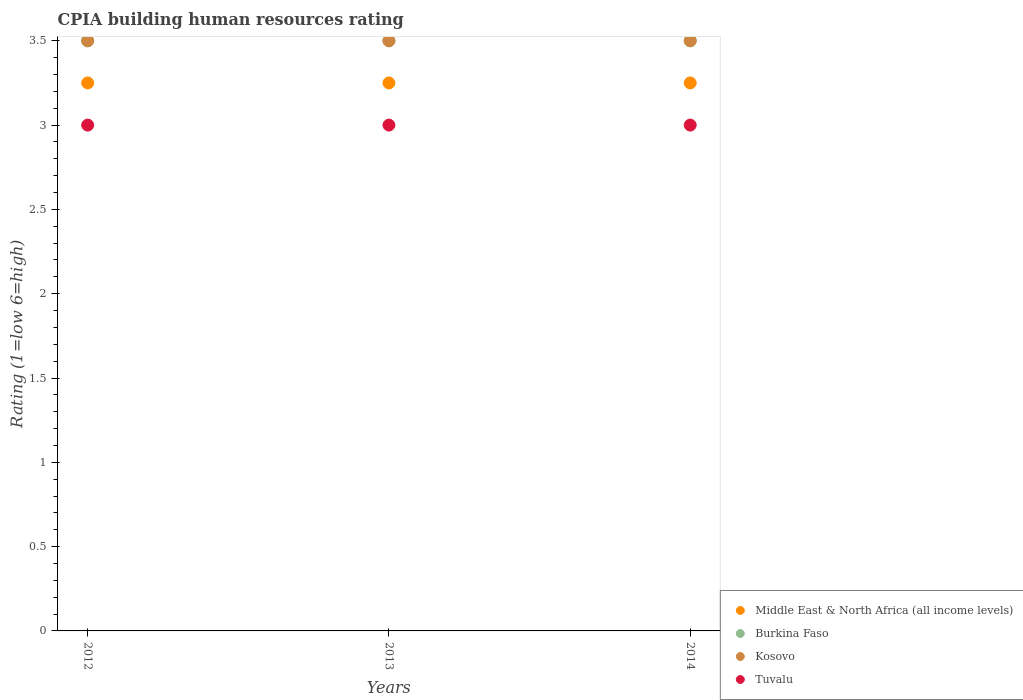What is the CPIA rating in Middle East & North Africa (all income levels) in 2014?
Give a very brief answer. 3.25. Across all years, what is the maximum CPIA rating in Burkina Faso?
Ensure brevity in your answer.  3.5. In which year was the CPIA rating in Tuvalu maximum?
Your response must be concise. 2012. In which year was the CPIA rating in Tuvalu minimum?
Your response must be concise. 2012. What is the total CPIA rating in Middle East & North Africa (all income levels) in the graph?
Provide a short and direct response. 9.75. What is the difference between the CPIA rating in Tuvalu in 2012 and that in 2014?
Your response must be concise. 0. In the year 2013, what is the difference between the CPIA rating in Kosovo and CPIA rating in Middle East & North Africa (all income levels)?
Ensure brevity in your answer.  0.25. In how many years, is the CPIA rating in Middle East & North Africa (all income levels) greater than 1.8?
Keep it short and to the point. 3. What is the ratio of the CPIA rating in Middle East & North Africa (all income levels) in 2012 to that in 2013?
Make the answer very short. 1. Is the difference between the CPIA rating in Kosovo in 2013 and 2014 greater than the difference between the CPIA rating in Middle East & North Africa (all income levels) in 2013 and 2014?
Your answer should be compact. No. What is the difference between the highest and the second highest CPIA rating in Middle East & North Africa (all income levels)?
Ensure brevity in your answer.  0. In how many years, is the CPIA rating in Middle East & North Africa (all income levels) greater than the average CPIA rating in Middle East & North Africa (all income levels) taken over all years?
Offer a terse response. 0. Is the sum of the CPIA rating in Burkina Faso in 2013 and 2014 greater than the maximum CPIA rating in Kosovo across all years?
Provide a succinct answer. Yes. Is it the case that in every year, the sum of the CPIA rating in Tuvalu and CPIA rating in Kosovo  is greater than the sum of CPIA rating in Middle East & North Africa (all income levels) and CPIA rating in Burkina Faso?
Your response must be concise. No. Are the values on the major ticks of Y-axis written in scientific E-notation?
Keep it short and to the point. No. How are the legend labels stacked?
Offer a terse response. Vertical. What is the title of the graph?
Provide a succinct answer. CPIA building human resources rating. What is the label or title of the Y-axis?
Offer a terse response. Rating (1=low 6=high). What is the Rating (1=low 6=high) of Burkina Faso in 2012?
Make the answer very short. 3.5. What is the Rating (1=low 6=high) in Kosovo in 2012?
Make the answer very short. 3.5. What is the Rating (1=low 6=high) in Tuvalu in 2012?
Your answer should be compact. 3. What is the Rating (1=low 6=high) in Middle East & North Africa (all income levels) in 2013?
Provide a succinct answer. 3.25. What is the Rating (1=low 6=high) in Burkina Faso in 2013?
Provide a succinct answer. 3.5. What is the Rating (1=low 6=high) of Kosovo in 2013?
Make the answer very short. 3.5. What is the Rating (1=low 6=high) in Tuvalu in 2013?
Provide a succinct answer. 3. What is the Rating (1=low 6=high) in Middle East & North Africa (all income levels) in 2014?
Your answer should be very brief. 3.25. What is the Rating (1=low 6=high) of Kosovo in 2014?
Offer a very short reply. 3.5. Across all years, what is the maximum Rating (1=low 6=high) of Middle East & North Africa (all income levels)?
Keep it short and to the point. 3.25. Across all years, what is the minimum Rating (1=low 6=high) in Burkina Faso?
Your answer should be very brief. 3.5. Across all years, what is the minimum Rating (1=low 6=high) in Kosovo?
Your answer should be very brief. 3.5. Across all years, what is the minimum Rating (1=low 6=high) in Tuvalu?
Make the answer very short. 3. What is the total Rating (1=low 6=high) of Middle East & North Africa (all income levels) in the graph?
Ensure brevity in your answer.  9.75. What is the total Rating (1=low 6=high) of Kosovo in the graph?
Your response must be concise. 10.5. What is the difference between the Rating (1=low 6=high) in Middle East & North Africa (all income levels) in 2012 and that in 2013?
Keep it short and to the point. 0. What is the difference between the Rating (1=low 6=high) of Kosovo in 2012 and that in 2013?
Your answer should be very brief. 0. What is the difference between the Rating (1=low 6=high) in Tuvalu in 2012 and that in 2013?
Your response must be concise. 0. What is the difference between the Rating (1=low 6=high) in Middle East & North Africa (all income levels) in 2012 and that in 2014?
Provide a short and direct response. 0. What is the difference between the Rating (1=low 6=high) of Tuvalu in 2012 and that in 2014?
Keep it short and to the point. 0. What is the difference between the Rating (1=low 6=high) of Kosovo in 2013 and that in 2014?
Your answer should be compact. 0. What is the difference between the Rating (1=low 6=high) in Middle East & North Africa (all income levels) in 2012 and the Rating (1=low 6=high) in Burkina Faso in 2013?
Keep it short and to the point. -0.25. What is the difference between the Rating (1=low 6=high) of Burkina Faso in 2012 and the Rating (1=low 6=high) of Tuvalu in 2013?
Offer a very short reply. 0.5. What is the difference between the Rating (1=low 6=high) in Middle East & North Africa (all income levels) in 2012 and the Rating (1=low 6=high) in Kosovo in 2014?
Offer a very short reply. -0.25. What is the difference between the Rating (1=low 6=high) of Middle East & North Africa (all income levels) in 2013 and the Rating (1=low 6=high) of Burkina Faso in 2014?
Offer a very short reply. -0.25. What is the difference between the Rating (1=low 6=high) of Burkina Faso in 2013 and the Rating (1=low 6=high) of Kosovo in 2014?
Offer a terse response. 0. What is the difference between the Rating (1=low 6=high) in Kosovo in 2013 and the Rating (1=low 6=high) in Tuvalu in 2014?
Your response must be concise. 0.5. What is the average Rating (1=low 6=high) in Burkina Faso per year?
Keep it short and to the point. 3.5. What is the average Rating (1=low 6=high) in Tuvalu per year?
Offer a very short reply. 3. In the year 2012, what is the difference between the Rating (1=low 6=high) in Middle East & North Africa (all income levels) and Rating (1=low 6=high) in Burkina Faso?
Your response must be concise. -0.25. In the year 2012, what is the difference between the Rating (1=low 6=high) in Middle East & North Africa (all income levels) and Rating (1=low 6=high) in Tuvalu?
Give a very brief answer. 0.25. In the year 2012, what is the difference between the Rating (1=low 6=high) of Burkina Faso and Rating (1=low 6=high) of Kosovo?
Make the answer very short. 0. In the year 2012, what is the difference between the Rating (1=low 6=high) of Burkina Faso and Rating (1=low 6=high) of Tuvalu?
Give a very brief answer. 0.5. In the year 2013, what is the difference between the Rating (1=low 6=high) of Middle East & North Africa (all income levels) and Rating (1=low 6=high) of Burkina Faso?
Your answer should be very brief. -0.25. In the year 2013, what is the difference between the Rating (1=low 6=high) of Middle East & North Africa (all income levels) and Rating (1=low 6=high) of Kosovo?
Offer a very short reply. -0.25. In the year 2014, what is the difference between the Rating (1=low 6=high) of Middle East & North Africa (all income levels) and Rating (1=low 6=high) of Kosovo?
Provide a succinct answer. -0.25. In the year 2014, what is the difference between the Rating (1=low 6=high) of Middle East & North Africa (all income levels) and Rating (1=low 6=high) of Tuvalu?
Provide a succinct answer. 0.25. In the year 2014, what is the difference between the Rating (1=low 6=high) in Burkina Faso and Rating (1=low 6=high) in Kosovo?
Provide a succinct answer. 0. In the year 2014, what is the difference between the Rating (1=low 6=high) of Burkina Faso and Rating (1=low 6=high) of Tuvalu?
Your response must be concise. 0.5. What is the ratio of the Rating (1=low 6=high) of Middle East & North Africa (all income levels) in 2012 to that in 2013?
Keep it short and to the point. 1. What is the ratio of the Rating (1=low 6=high) of Middle East & North Africa (all income levels) in 2012 to that in 2014?
Offer a terse response. 1. What is the ratio of the Rating (1=low 6=high) of Burkina Faso in 2012 to that in 2014?
Offer a terse response. 1. What is the ratio of the Rating (1=low 6=high) in Middle East & North Africa (all income levels) in 2013 to that in 2014?
Your response must be concise. 1. What is the ratio of the Rating (1=low 6=high) in Tuvalu in 2013 to that in 2014?
Give a very brief answer. 1. What is the difference between the highest and the second highest Rating (1=low 6=high) of Burkina Faso?
Provide a short and direct response. 0. What is the difference between the highest and the second highest Rating (1=low 6=high) of Kosovo?
Your response must be concise. 0. What is the difference between the highest and the second highest Rating (1=low 6=high) of Tuvalu?
Keep it short and to the point. 0. What is the difference between the highest and the lowest Rating (1=low 6=high) of Burkina Faso?
Your answer should be very brief. 0. 